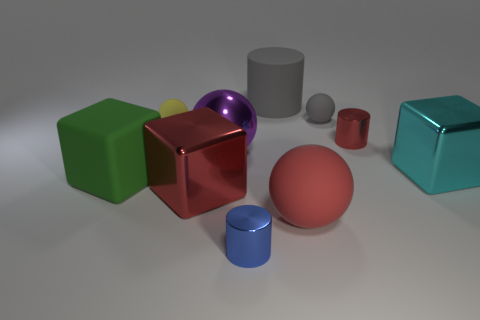Do the rubber cylinder and the big sphere right of the big purple thing have the same color? No, they do not have the same color. The rubber cylinder appears to have a grey color, while the big sphere on the right side of the big purple object has a pinkish hue. 